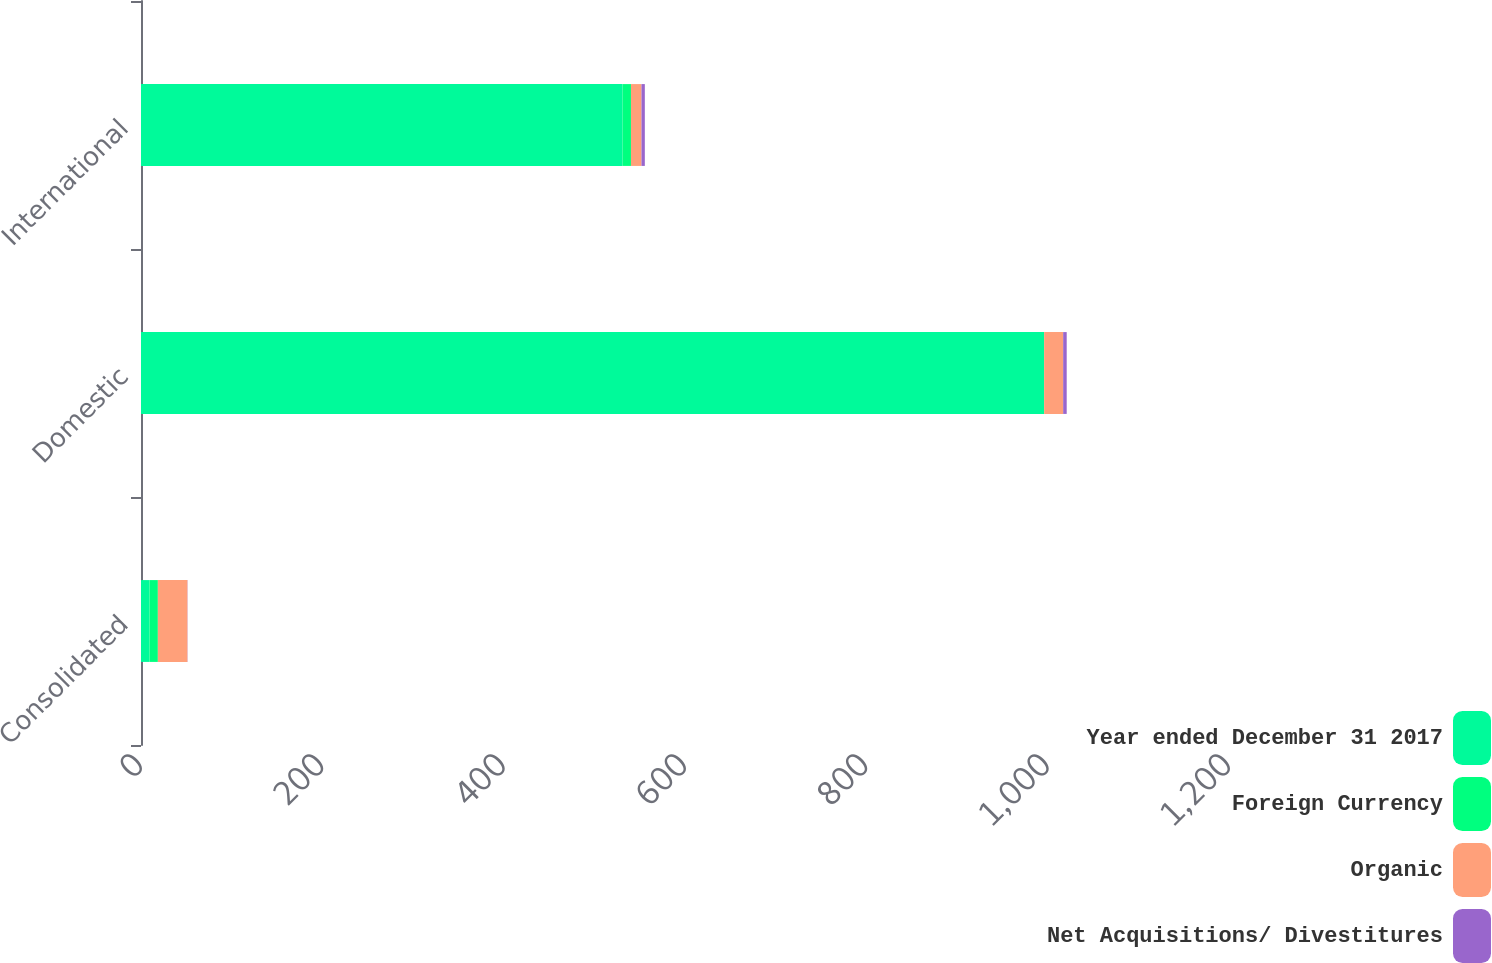Convert chart. <chart><loc_0><loc_0><loc_500><loc_500><stacked_bar_chart><ecel><fcel>Consolidated<fcel>Domestic<fcel>International<nl><fcel>Year ended December 31 2017<fcel>9.3<fcel>996.1<fcel>531.1<nl><fcel>Foreign Currency<fcel>9.3<fcel>0<fcel>9.3<nl><fcel>Organic<fcel>32.6<fcel>21<fcel>11.6<nl><fcel>Net Acquisitions/ Divestitures<fcel>0.2<fcel>3.9<fcel>3.7<nl></chart> 